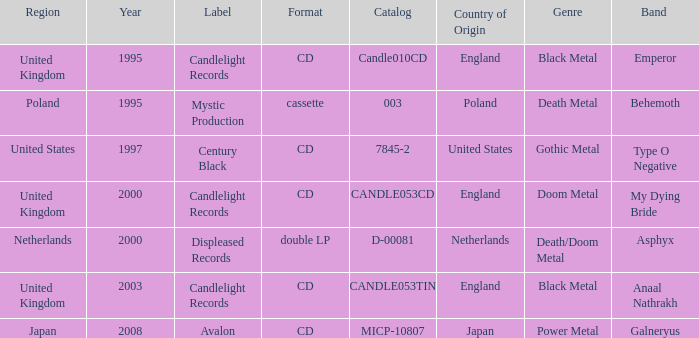What was the Candlelight Records Catalog of Candle053tin format? CD. 